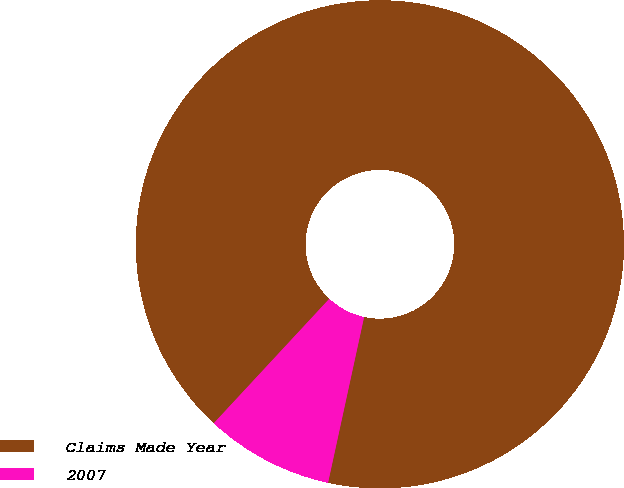<chart> <loc_0><loc_0><loc_500><loc_500><pie_chart><fcel>Claims Made Year<fcel>2007<nl><fcel>91.5%<fcel>8.5%<nl></chart> 